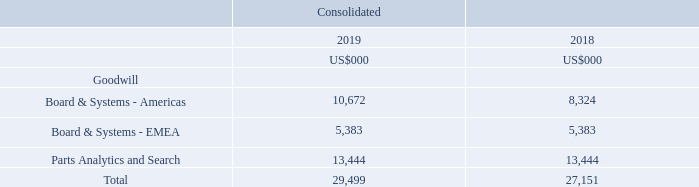A segment-level summary of the goodwill allocation is presented below.
The recoverable amount of the group’s intangible assets has been assessed based on value-in-use calculations. The value in use is calculated using a discounted cash flow methodology covering a four year period plus terminal value.
Cash flow forecasts 

Cash flow forecasts are post-tax and based on the most recent financial projections covering a maximum of five years. Financial projections are based on assumptions that represent management’s best estimates.
Revenue growth rates 

Revenue growth rates used are based on management’s latest four-year plan. Four-year growth rates averaged between 8.8% to 12.1% for these CGUs (Board & Systems - Americas 8.8%, Board & Systems - EMEA 12.1% and Parts Analytics and Search 11.8%). Sensitivity testing was performed on these CGUs and a reasonably possible decline in these rates would not cause the carrying value of any of these CGUs to exceed its recoverable amount.
Terminal value 

The terminal value calculated after year four is determined using the perpetual growth model, having regard to the weighted average cost of capital (WACC) and terminal growth factor appropriate to each CGU. Terminal growth rates used in the financial projections was 2.0%.
Discount rates 

Discount rates used are WACC and include a premium for market risks appropriate to each country in which the CGU operates. WACCs averaged 8.9% (Board & Systems - Americas 9.1%, Board & Systems - EMEA 8.6% and Parts Analytics and Search 9.1%).
Sensitivity  Any reasonable change to the above key assumptions would not cause the carrying value of any of the remaining CGU’s to materially exceed its recoverable amount.
Accounting policy for intangible assets
Goodwill 

Goodwill arises on the acquisition of a business. Goodwill is not amortised. Instead, goodwill is tested annually for impairment, or more frequently if events or changes in circumstances indicate that it might be impaired, and is carried at cost less accumulated impairment losses. Impairment losses on goodwill are taken to profit or loss and are not subsequently reversed.
Intellectual property 

Significant costs associated with intellectual property are deferred and amortised on a straight-line basis over the period of their expected benefit, being their finite life of 5 to 10 years.
Customer relationships 

Customer relationships acquired in a business combination are amortised on a straight-line basis over the period of their expected benefit, being their finite life of 10 to 15 years.
Software intangibles 

Software intangibles arise from costs associated with the direct development and implementation on an internal project on new and existing software utilised by the group which demonstrates the technical feasibility of providing future economic benefits and amortised on a straight-line basis over the period of their expected benefit, being their finite life of 2 to 5 years.
Accounting policy for intangible assets
What are the segments of Goodwill allocations in the table? Board & systems - americas, board & systems - emea, parts analytics and search. What were the terminal growth rates used in the financial projections? 2.0%. What is the finite life of intellectual property? 5 to 10 years. Which segment of total goodwill was the largest in 2019? Find the largest number in COL3 rows 5 to 7 and the corresponding component
Answer: parts analytics and search. How many segments in 2019 had a goodwill value of above 5,000 thousand?  Board & Systems - Americas ## Board & Systems - EMEA ## Parts Analytics and Search 
Answer: 3. What is the percentage increase in the total goodwill allocation from 2018 to 2019?
Answer scale should be: percent. (29,499-27,151)/27,151
Answer: 8.65. 